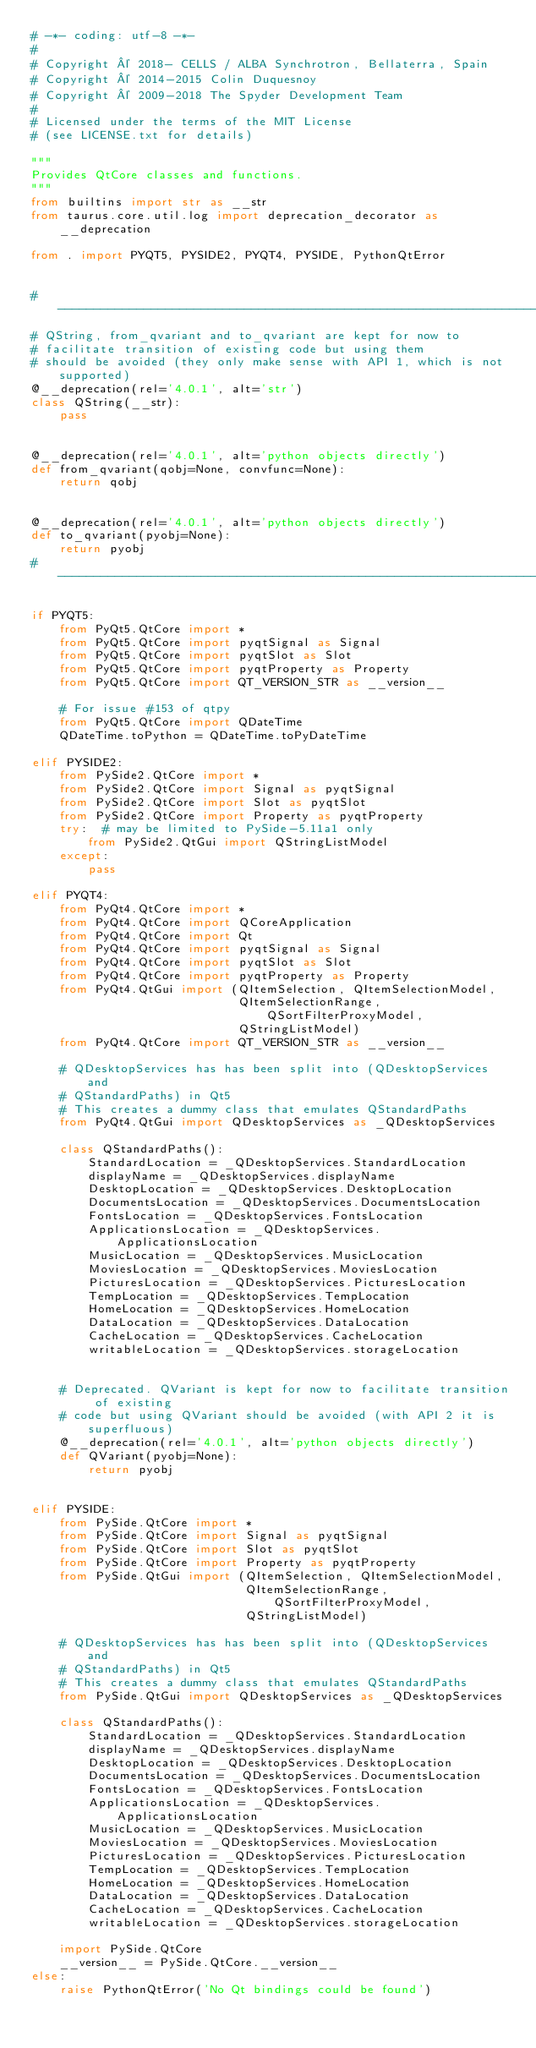<code> <loc_0><loc_0><loc_500><loc_500><_Python_># -*- coding: utf-8 -*-
#
# Copyright © 2018- CELLS / ALBA Synchrotron, Bellaterra, Spain
# Copyright © 2014-2015 Colin Duquesnoy
# Copyright © 2009-2018 The Spyder Development Team
#
# Licensed under the terms of the MIT License
# (see LICENSE.txt for details)

"""
Provides QtCore classes and functions.
"""
from builtins import str as __str
from taurus.core.util.log import deprecation_decorator as __deprecation

from . import PYQT5, PYSIDE2, PYQT4, PYSIDE, PythonQtError


# --------------------------------------------------------------------------
# QString, from_qvariant and to_qvariant are kept for now to
# facilitate transition of existing code but using them
# should be avoided (they only make sense with API 1, which is not supported)
@__deprecation(rel='4.0.1', alt='str')
class QString(__str):
    pass


@__deprecation(rel='4.0.1', alt='python objects directly')
def from_qvariant(qobj=None, convfunc=None):
    return qobj


@__deprecation(rel='4.0.1', alt='python objects directly')
def to_qvariant(pyobj=None):
    return pyobj
# --------------------------------------------------------------------------

if PYQT5:
    from PyQt5.QtCore import *
    from PyQt5.QtCore import pyqtSignal as Signal
    from PyQt5.QtCore import pyqtSlot as Slot
    from PyQt5.QtCore import pyqtProperty as Property
    from PyQt5.QtCore import QT_VERSION_STR as __version__

    # For issue #153 of qtpy
    from PyQt5.QtCore import QDateTime
    QDateTime.toPython = QDateTime.toPyDateTime

elif PYSIDE2:
    from PySide2.QtCore import *
    from PySide2.QtCore import Signal as pyqtSignal
    from PySide2.QtCore import Slot as pyqtSlot
    from PySide2.QtCore import Property as pyqtProperty
    try:  # may be limited to PySide-5.11a1 only
        from PySide2.QtGui import QStringListModel
    except:
        pass

elif PYQT4:
    from PyQt4.QtCore import *
    from PyQt4.QtCore import QCoreApplication
    from PyQt4.QtCore import Qt
    from PyQt4.QtCore import pyqtSignal as Signal
    from PyQt4.QtCore import pyqtSlot as Slot
    from PyQt4.QtCore import pyqtProperty as Property
    from PyQt4.QtGui import (QItemSelection, QItemSelectionModel,
                             QItemSelectionRange, QSortFilterProxyModel,
                             QStringListModel)
    from PyQt4.QtCore import QT_VERSION_STR as __version__

    # QDesktopServices has has been split into (QDesktopServices and
    # QStandardPaths) in Qt5
    # This creates a dummy class that emulates QStandardPaths
    from PyQt4.QtGui import QDesktopServices as _QDesktopServices

    class QStandardPaths():
        StandardLocation = _QDesktopServices.StandardLocation
        displayName = _QDesktopServices.displayName
        DesktopLocation = _QDesktopServices.DesktopLocation
        DocumentsLocation = _QDesktopServices.DocumentsLocation
        FontsLocation = _QDesktopServices.FontsLocation
        ApplicationsLocation = _QDesktopServices.ApplicationsLocation
        MusicLocation = _QDesktopServices.MusicLocation
        MoviesLocation = _QDesktopServices.MoviesLocation
        PicturesLocation = _QDesktopServices.PicturesLocation
        TempLocation = _QDesktopServices.TempLocation
        HomeLocation = _QDesktopServices.HomeLocation
        DataLocation = _QDesktopServices.DataLocation
        CacheLocation = _QDesktopServices.CacheLocation
        writableLocation = _QDesktopServices.storageLocation


    # Deprecated. QVariant is kept for now to facilitate transition of existing
    # code but using QVariant should be avoided (with API 2 it is superfluous)
    @__deprecation(rel='4.0.1', alt='python objects directly')
    def QVariant(pyobj=None):
        return pyobj


elif PYSIDE:
    from PySide.QtCore import *
    from PySide.QtCore import Signal as pyqtSignal
    from PySide.QtCore import Slot as pyqtSlot
    from PySide.QtCore import Property as pyqtProperty
    from PySide.QtGui import (QItemSelection, QItemSelectionModel,
                              QItemSelectionRange, QSortFilterProxyModel,
                              QStringListModel)

    # QDesktopServices has has been split into (QDesktopServices and
    # QStandardPaths) in Qt5
    # This creates a dummy class that emulates QStandardPaths
    from PySide.QtGui import QDesktopServices as _QDesktopServices

    class QStandardPaths():
        StandardLocation = _QDesktopServices.StandardLocation
        displayName = _QDesktopServices.displayName
        DesktopLocation = _QDesktopServices.DesktopLocation
        DocumentsLocation = _QDesktopServices.DocumentsLocation
        FontsLocation = _QDesktopServices.FontsLocation
        ApplicationsLocation = _QDesktopServices.ApplicationsLocation
        MusicLocation = _QDesktopServices.MusicLocation
        MoviesLocation = _QDesktopServices.MoviesLocation
        PicturesLocation = _QDesktopServices.PicturesLocation
        TempLocation = _QDesktopServices.TempLocation
        HomeLocation = _QDesktopServices.HomeLocation
        DataLocation = _QDesktopServices.DataLocation
        CacheLocation = _QDesktopServices.CacheLocation
        writableLocation = _QDesktopServices.storageLocation

    import PySide.QtCore
    __version__ = PySide.QtCore.__version__
else:
    raise PythonQtError('No Qt bindings could be found')</code> 